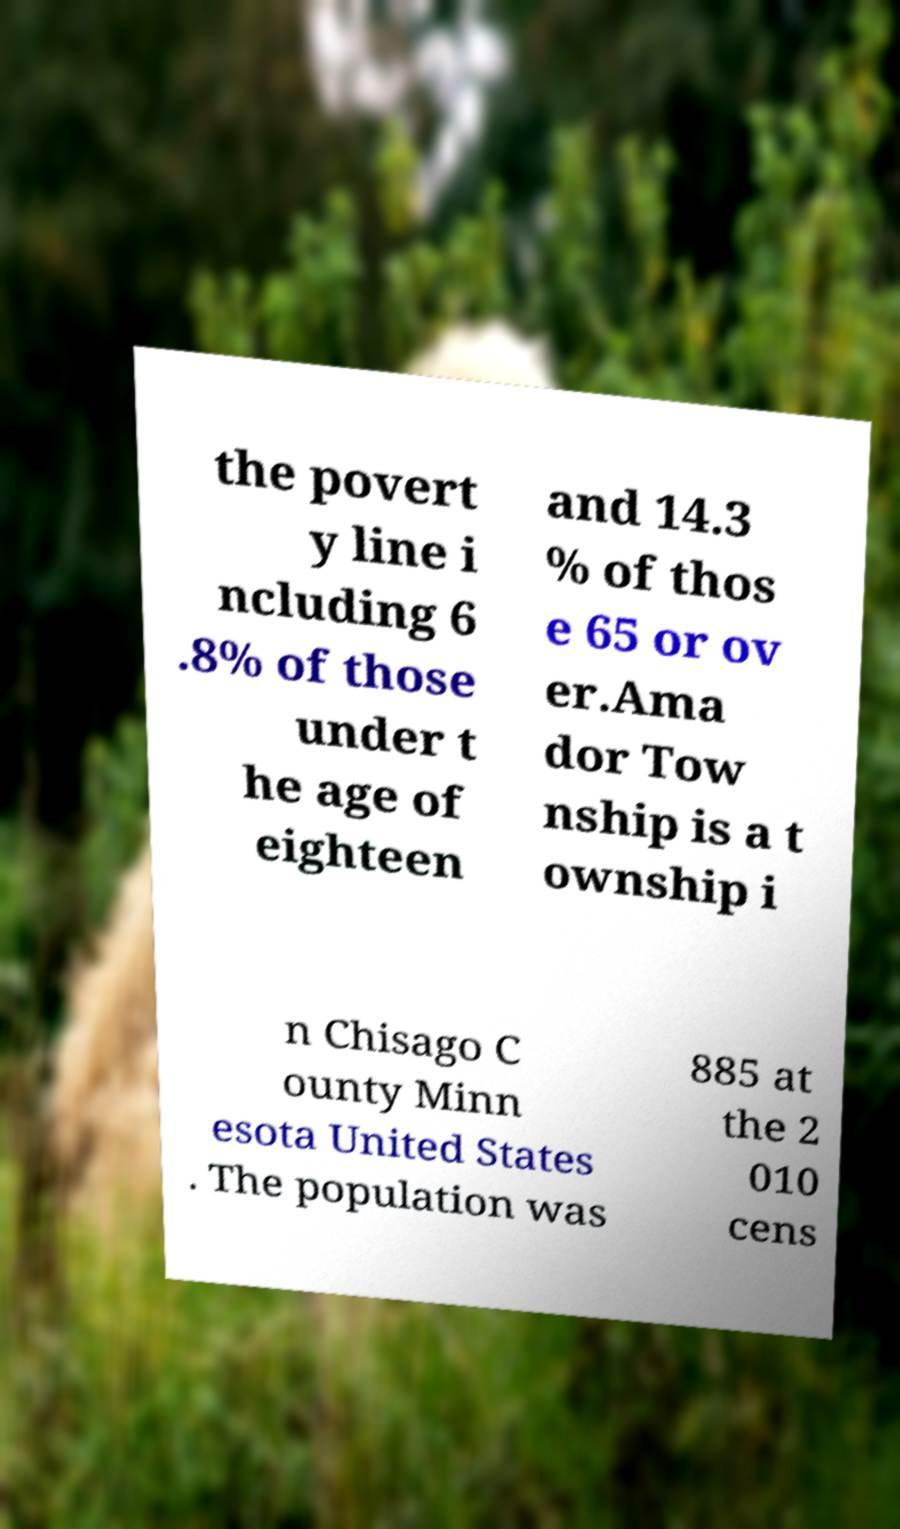What messages or text are displayed in this image? I need them in a readable, typed format. the povert y line i ncluding 6 .8% of those under t he age of eighteen and 14.3 % of thos e 65 or ov er.Ama dor Tow nship is a t ownship i n Chisago C ounty Minn esota United States . The population was 885 at the 2 010 cens 